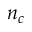Convert formula to latex. <formula><loc_0><loc_0><loc_500><loc_500>n _ { c }</formula> 